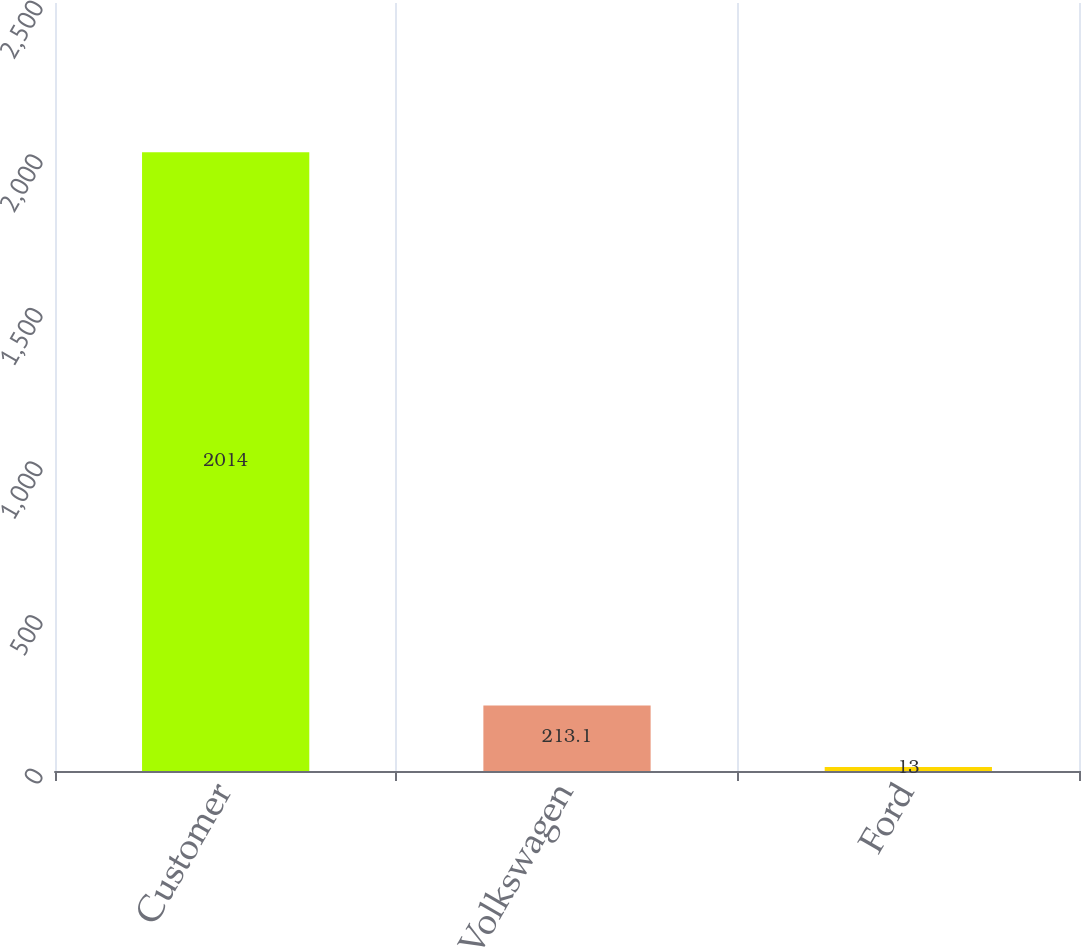<chart> <loc_0><loc_0><loc_500><loc_500><bar_chart><fcel>Customer<fcel>Volkswagen<fcel>Ford<nl><fcel>2014<fcel>213.1<fcel>13<nl></chart> 